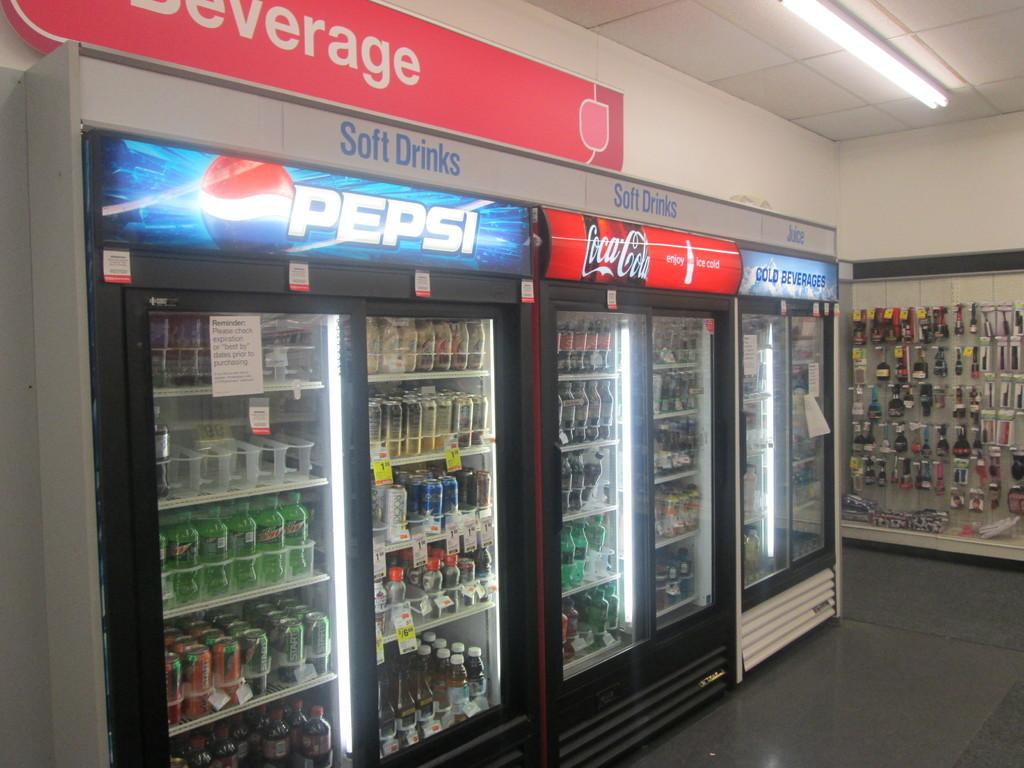<image>
Present a compact description of the photo's key features. The beverage coolers are located underneath the beverage signage. 